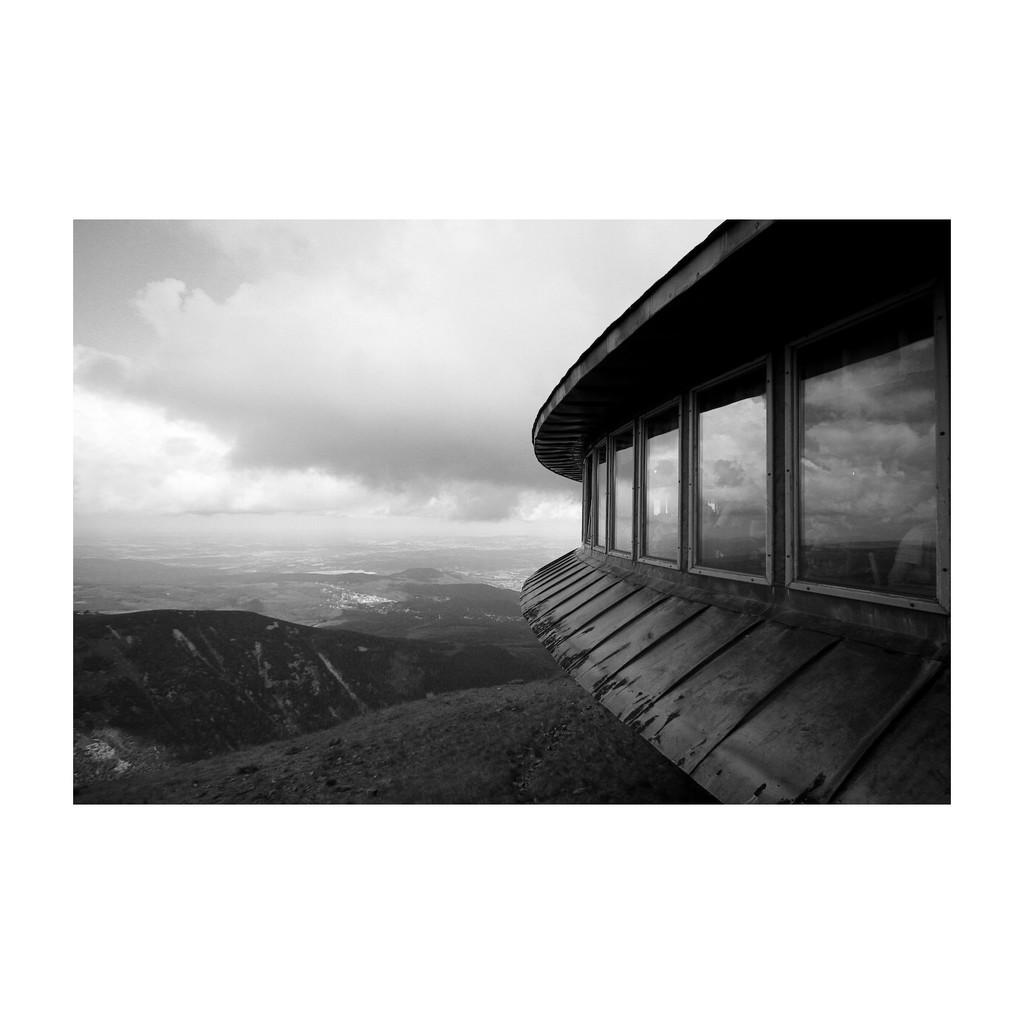What type of natural formation can be seen in the image? There are mountains in the image. What is located on the right side of the image? There is a glass wall on the right side of the image. What material is used for the wooden sheet in the image? The wooden sheet in the image is made of wood. What is visible at the top of the image? The sky is visible at the top of the image. What is the condition of the sky in the image? The sky appears to be cloudy in the image. Can you see a fire burning in the image? There is no fire present in the image. Is there a wave crashing on the shore in the image? There is no shore or wave depicted in the image; it features mountains and a glass wall. 